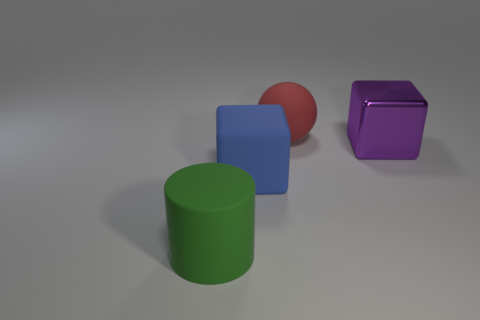Add 1 small gray rubber things. How many objects exist? 5 Subtract all cylinders. How many objects are left? 3 Subtract 0 gray cubes. How many objects are left? 4 Subtract all brown blocks. Subtract all brown spheres. How many blocks are left? 2 Subtract all large purple shiny blocks. Subtract all blocks. How many objects are left? 1 Add 4 large blocks. How many large blocks are left? 6 Add 1 green shiny cubes. How many green shiny cubes exist? 1 